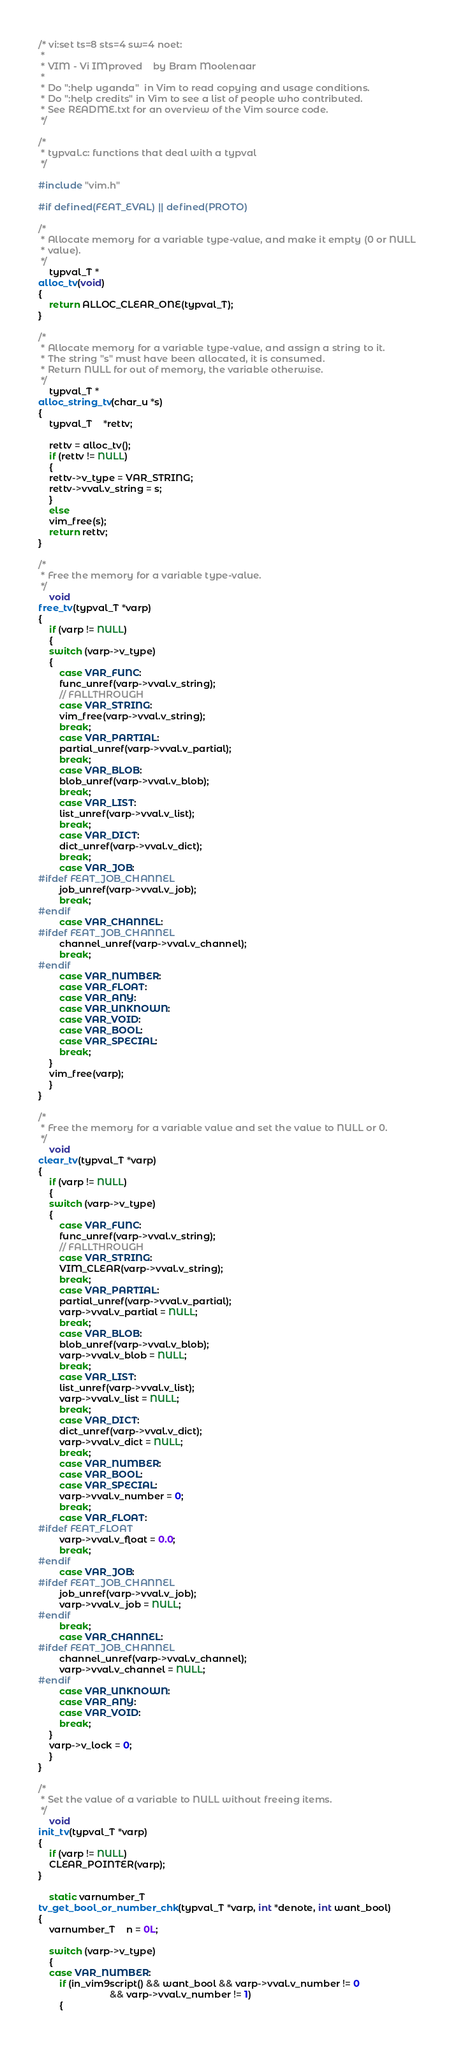<code> <loc_0><loc_0><loc_500><loc_500><_C_>/* vi:set ts=8 sts=4 sw=4 noet:
 *
 * VIM - Vi IMproved	by Bram Moolenaar
 *
 * Do ":help uganda"  in Vim to read copying and usage conditions.
 * Do ":help credits" in Vim to see a list of people who contributed.
 * See README.txt for an overview of the Vim source code.
 */

/*
 * typval.c: functions that deal with a typval
 */

#include "vim.h"

#if defined(FEAT_EVAL) || defined(PROTO)

/*
 * Allocate memory for a variable type-value, and make it empty (0 or NULL
 * value).
 */
    typval_T *
alloc_tv(void)
{
    return ALLOC_CLEAR_ONE(typval_T);
}

/*
 * Allocate memory for a variable type-value, and assign a string to it.
 * The string "s" must have been allocated, it is consumed.
 * Return NULL for out of memory, the variable otherwise.
 */
    typval_T *
alloc_string_tv(char_u *s)
{
    typval_T	*rettv;

    rettv = alloc_tv();
    if (rettv != NULL)
    {
	rettv->v_type = VAR_STRING;
	rettv->vval.v_string = s;
    }
    else
	vim_free(s);
    return rettv;
}

/*
 * Free the memory for a variable type-value.
 */
    void
free_tv(typval_T *varp)
{
    if (varp != NULL)
    {
	switch (varp->v_type)
	{
	    case VAR_FUNC:
		func_unref(varp->vval.v_string);
		// FALLTHROUGH
	    case VAR_STRING:
		vim_free(varp->vval.v_string);
		break;
	    case VAR_PARTIAL:
		partial_unref(varp->vval.v_partial);
		break;
	    case VAR_BLOB:
		blob_unref(varp->vval.v_blob);
		break;
	    case VAR_LIST:
		list_unref(varp->vval.v_list);
		break;
	    case VAR_DICT:
		dict_unref(varp->vval.v_dict);
		break;
	    case VAR_JOB:
#ifdef FEAT_JOB_CHANNEL
		job_unref(varp->vval.v_job);
		break;
#endif
	    case VAR_CHANNEL:
#ifdef FEAT_JOB_CHANNEL
		channel_unref(varp->vval.v_channel);
		break;
#endif
	    case VAR_NUMBER:
	    case VAR_FLOAT:
	    case VAR_ANY:
	    case VAR_UNKNOWN:
	    case VAR_VOID:
	    case VAR_BOOL:
	    case VAR_SPECIAL:
		break;
	}
	vim_free(varp);
    }
}

/*
 * Free the memory for a variable value and set the value to NULL or 0.
 */
    void
clear_tv(typval_T *varp)
{
    if (varp != NULL)
    {
	switch (varp->v_type)
	{
	    case VAR_FUNC:
		func_unref(varp->vval.v_string);
		// FALLTHROUGH
	    case VAR_STRING:
		VIM_CLEAR(varp->vval.v_string);
		break;
	    case VAR_PARTIAL:
		partial_unref(varp->vval.v_partial);
		varp->vval.v_partial = NULL;
		break;
	    case VAR_BLOB:
		blob_unref(varp->vval.v_blob);
		varp->vval.v_blob = NULL;
		break;
	    case VAR_LIST:
		list_unref(varp->vval.v_list);
		varp->vval.v_list = NULL;
		break;
	    case VAR_DICT:
		dict_unref(varp->vval.v_dict);
		varp->vval.v_dict = NULL;
		break;
	    case VAR_NUMBER:
	    case VAR_BOOL:
	    case VAR_SPECIAL:
		varp->vval.v_number = 0;
		break;
	    case VAR_FLOAT:
#ifdef FEAT_FLOAT
		varp->vval.v_float = 0.0;
		break;
#endif
	    case VAR_JOB:
#ifdef FEAT_JOB_CHANNEL
		job_unref(varp->vval.v_job);
		varp->vval.v_job = NULL;
#endif
		break;
	    case VAR_CHANNEL:
#ifdef FEAT_JOB_CHANNEL
		channel_unref(varp->vval.v_channel);
		varp->vval.v_channel = NULL;
#endif
	    case VAR_UNKNOWN:
	    case VAR_ANY:
	    case VAR_VOID:
		break;
	}
	varp->v_lock = 0;
    }
}

/*
 * Set the value of a variable to NULL without freeing items.
 */
    void
init_tv(typval_T *varp)
{
    if (varp != NULL)
	CLEAR_POINTER(varp);
}

    static varnumber_T
tv_get_bool_or_number_chk(typval_T *varp, int *denote, int want_bool)
{
    varnumber_T	n = 0L;

    switch (varp->v_type)
    {
	case VAR_NUMBER:
	    if (in_vim9script() && want_bool && varp->vval.v_number != 0
						   && varp->vval.v_number != 1)
	    {</code> 